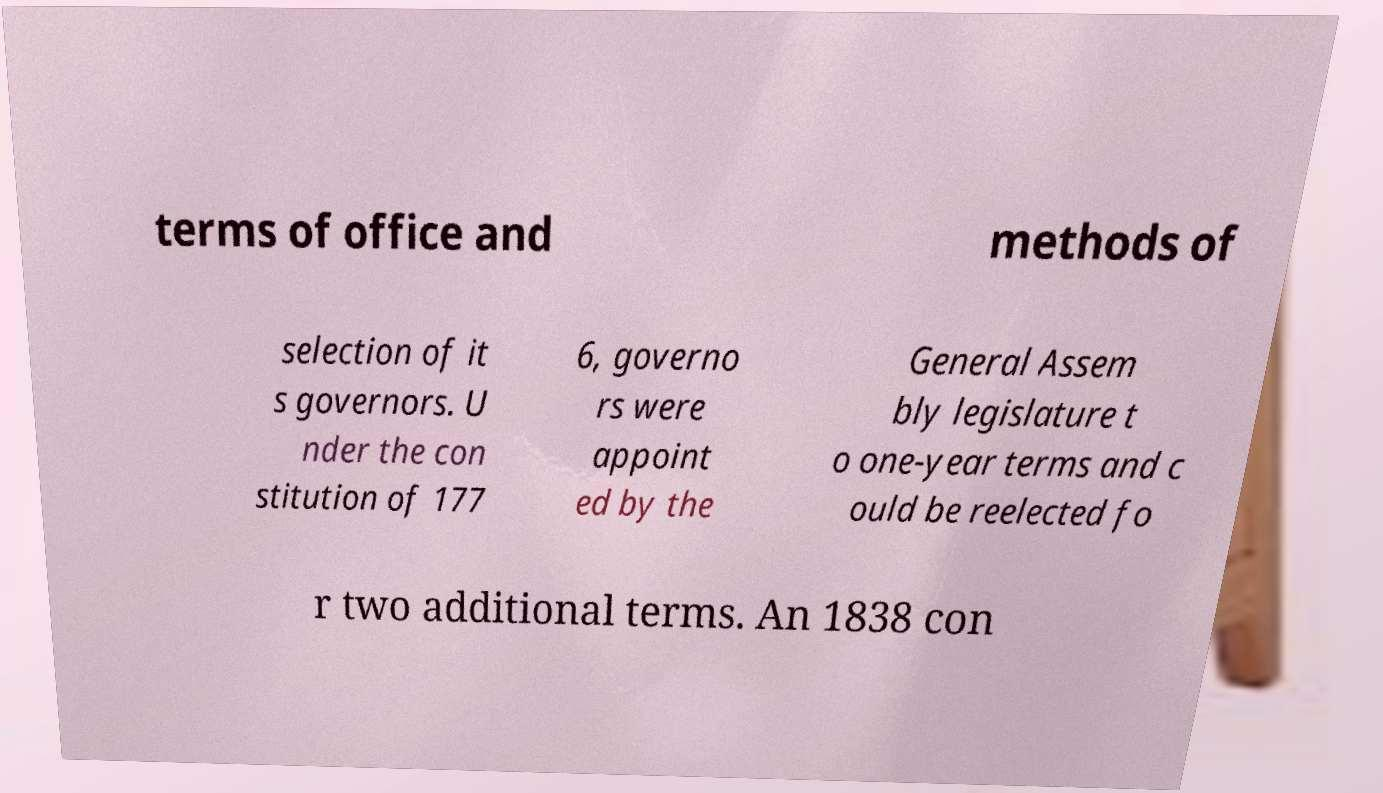I need the written content from this picture converted into text. Can you do that? terms of office and methods of selection of it s governors. U nder the con stitution of 177 6, governo rs were appoint ed by the General Assem bly legislature t o one-year terms and c ould be reelected fo r two additional terms. An 1838 con 